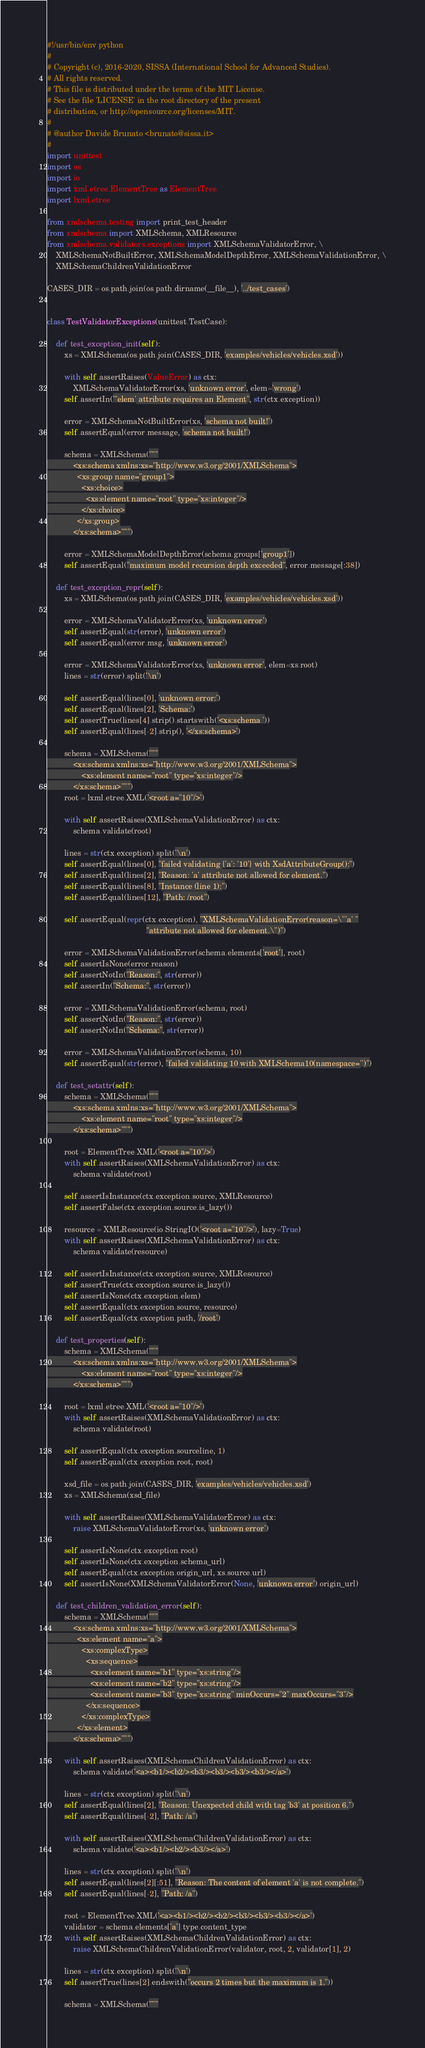Convert code to text. <code><loc_0><loc_0><loc_500><loc_500><_Python_>#!/usr/bin/env python
#
# Copyright (c), 2016-2020, SISSA (International School for Advanced Studies).
# All rights reserved.
# This file is distributed under the terms of the MIT License.
# See the file 'LICENSE' in the root directory of the present
# distribution, or http://opensource.org/licenses/MIT.
#
# @author Davide Brunato <brunato@sissa.it>
#
import unittest
import os
import io
import xml.etree.ElementTree as ElementTree
import lxml.etree

from xmlschema.testing import print_test_header
from xmlschema import XMLSchema, XMLResource
from xmlschema.validators.exceptions import XMLSchemaValidatorError, \
    XMLSchemaNotBuiltError, XMLSchemaModelDepthError, XMLSchemaValidationError, \
    XMLSchemaChildrenValidationError

CASES_DIR = os.path.join(os.path.dirname(__file__), '../test_cases')


class TestValidatorExceptions(unittest.TestCase):

    def test_exception_init(self):
        xs = XMLSchema(os.path.join(CASES_DIR, 'examples/vehicles/vehicles.xsd'))

        with self.assertRaises(ValueError) as ctx:
            XMLSchemaValidatorError(xs, 'unknown error', elem='wrong')
        self.assertIn("'elem' attribute requires an Element", str(ctx.exception))

        error = XMLSchemaNotBuiltError(xs, 'schema not built!')
        self.assertEqual(error.message, 'schema not built!')

        schema = XMLSchema("""
            <xs:schema xmlns:xs="http://www.w3.org/2001/XMLSchema">
              <xs:group name="group1">
                <xs:choice>
                  <xs:element name="root" type="xs:integer"/>
                </xs:choice>
              </xs:group>
            </xs:schema>""")

        error = XMLSchemaModelDepthError(schema.groups['group1'])
        self.assertEqual("maximum model recursion depth exceeded", error.message[:38])

    def test_exception_repr(self):
        xs = XMLSchema(os.path.join(CASES_DIR, 'examples/vehicles/vehicles.xsd'))

        error = XMLSchemaValidatorError(xs, 'unknown error')
        self.assertEqual(str(error), 'unknown error')
        self.assertEqual(error.msg, 'unknown error')

        error = XMLSchemaValidatorError(xs, 'unknown error', elem=xs.root)
        lines = str(error).split('\n')

        self.assertEqual(lines[0], 'unknown error:')
        self.assertEqual(lines[2], 'Schema:')
        self.assertTrue(lines[4].strip().startswith('<xs:schema '))
        self.assertEqual(lines[-2].strip(), '</xs:schema>')

        schema = XMLSchema("""
            <xs:schema xmlns:xs="http://www.w3.org/2001/XMLSchema">
                <xs:element name="root" type="xs:integer"/>
            </xs:schema>""")
        root = lxml.etree.XML('<root a="10"/>')

        with self.assertRaises(XMLSchemaValidationError) as ctx:
            schema.validate(root)

        lines = str(ctx.exception).split('\n')
        self.assertEqual(lines[0], "failed validating {'a': '10'} with XsdAttributeGroup():")
        self.assertEqual(lines[2], "Reason: 'a' attribute not allowed for element.")
        self.assertEqual(lines[8], "Instance (line 1):")
        self.assertEqual(lines[12], "Path: /root")

        self.assertEqual(repr(ctx.exception), "XMLSchemaValidationError(reason=\"'a' "
                                              "attribute not allowed for element.\")")

        error = XMLSchemaValidationError(schema.elements['root'], root)
        self.assertIsNone(error.reason)
        self.assertNotIn("Reason:", str(error))
        self.assertIn("Schema:", str(error))

        error = XMLSchemaValidationError(schema, root)
        self.assertNotIn("Reason:", str(error))
        self.assertNotIn("Schema:", str(error))

        error = XMLSchemaValidationError(schema, 10)
        self.assertEqual(str(error), "failed validating 10 with XMLSchema10(namespace='')")

    def test_setattr(self):
        schema = XMLSchema("""
            <xs:schema xmlns:xs="http://www.w3.org/2001/XMLSchema">
                <xs:element name="root" type="xs:integer"/>
            </xs:schema>""")

        root = ElementTree.XML('<root a="10"/>')
        with self.assertRaises(XMLSchemaValidationError) as ctx:
            schema.validate(root)

        self.assertIsInstance(ctx.exception.source, XMLResource)
        self.assertFalse(ctx.exception.source.is_lazy())

        resource = XMLResource(io.StringIO('<root a="10"/>'), lazy=True)
        with self.assertRaises(XMLSchemaValidationError) as ctx:
            schema.validate(resource)

        self.assertIsInstance(ctx.exception.source, XMLResource)
        self.assertTrue(ctx.exception.source.is_lazy())
        self.assertIsNone(ctx.exception.elem)
        self.assertEqual(ctx.exception.source, resource)
        self.assertEqual(ctx.exception.path, '/root')

    def test_properties(self):
        schema = XMLSchema("""
            <xs:schema xmlns:xs="http://www.w3.org/2001/XMLSchema">
                <xs:element name="root" type="xs:integer"/>
            </xs:schema>""")

        root = lxml.etree.XML('<root a="10"/>')
        with self.assertRaises(XMLSchemaValidationError) as ctx:
            schema.validate(root)

        self.assertEqual(ctx.exception.sourceline, 1)
        self.assertEqual(ctx.exception.root, root)

        xsd_file = os.path.join(CASES_DIR, 'examples/vehicles/vehicles.xsd')
        xs = XMLSchema(xsd_file)

        with self.assertRaises(XMLSchemaValidatorError) as ctx:
            raise XMLSchemaValidatorError(xs, 'unknown error')

        self.assertIsNone(ctx.exception.root)
        self.assertIsNone(ctx.exception.schema_url)
        self.assertEqual(ctx.exception.origin_url, xs.source.url)
        self.assertIsNone(XMLSchemaValidatorError(None, 'unknown error').origin_url)

    def test_children_validation_error(self):
        schema = XMLSchema("""
            <xs:schema xmlns:xs="http://www.w3.org/2001/XMLSchema">
              <xs:element name="a">
                <xs:complexType>
                  <xs:sequence>
                    <xs:element name="b1" type="xs:string"/>
                    <xs:element name="b2" type="xs:string"/>
                    <xs:element name="b3" type="xs:string" minOccurs="2" maxOccurs="3"/>
                  </xs:sequence>
                </xs:complexType>
              </xs:element>
            </xs:schema>""")

        with self.assertRaises(XMLSchemaChildrenValidationError) as ctx:
            schema.validate('<a><b1/><b2/><b3/><b3/><b3/><b3/></a>')

        lines = str(ctx.exception).split('\n')
        self.assertEqual(lines[2], "Reason: Unexpected child with tag 'b3' at position 6.")
        self.assertEqual(lines[-2], "Path: /a")

        with self.assertRaises(XMLSchemaChildrenValidationError) as ctx:
            schema.validate('<a><b1/><b2/><b3/></a>')

        lines = str(ctx.exception).split('\n')
        self.assertEqual(lines[2][:51], "Reason: The content of element 'a' is not complete.")
        self.assertEqual(lines[-2], "Path: /a")

        root = ElementTree.XML('<a><b1/><b2/><b2/><b3/><b3/><b3/></a>')
        validator = schema.elements['a'].type.content_type
        with self.assertRaises(XMLSchemaChildrenValidationError) as ctx:
            raise XMLSchemaChildrenValidationError(validator, root, 2, validator[1], 2)

        lines = str(ctx.exception).split('\n')
        self.assertTrue(lines[2].endswith("occurs 2 times but the maximum is 1."))

        schema = XMLSchema("""</code> 